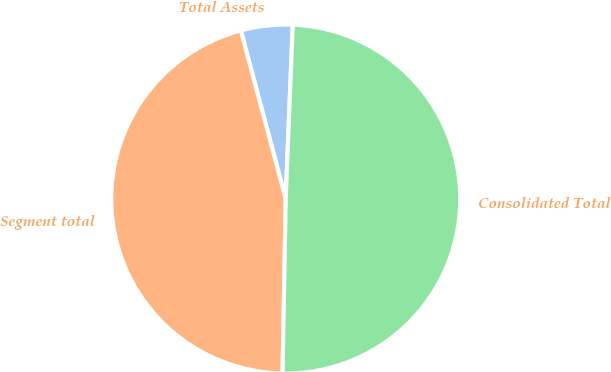Convert chart to OTSL. <chart><loc_0><loc_0><loc_500><loc_500><pie_chart><fcel>Total Assets<fcel>Segment total<fcel>Consolidated Total<nl><fcel>4.79%<fcel>45.56%<fcel>49.64%<nl></chart> 